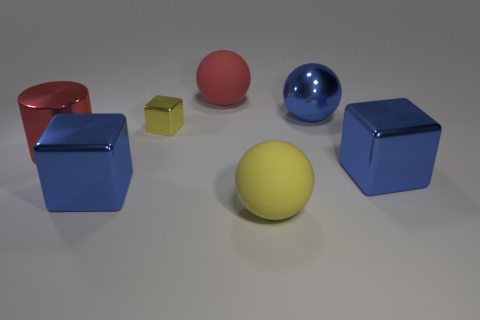Add 2 small cyan cylinders. How many objects exist? 9 Subtract all blocks. How many objects are left? 4 Subtract 0 purple blocks. How many objects are left? 7 Subtract all large blue spheres. Subtract all small cubes. How many objects are left? 5 Add 5 large balls. How many large balls are left? 8 Add 6 big blue cylinders. How many big blue cylinders exist? 6 